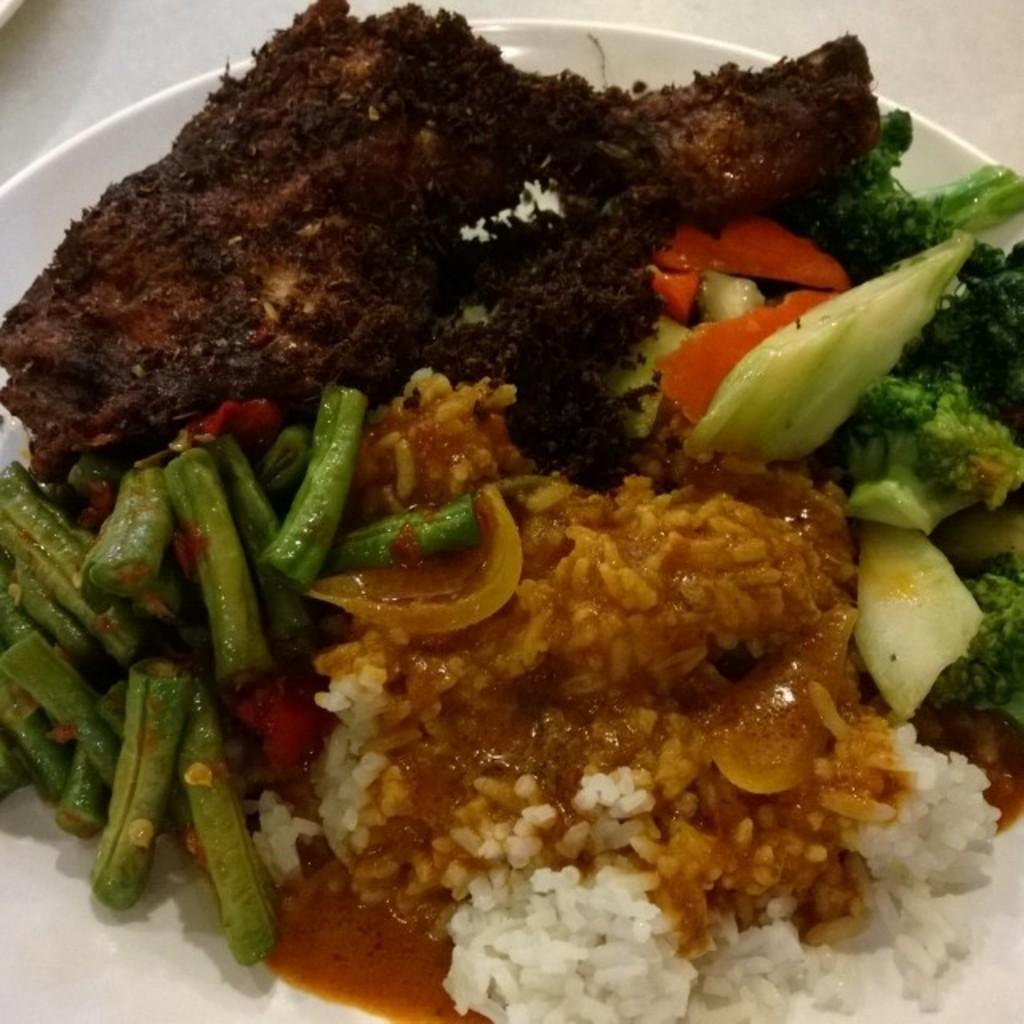What is present on the serving plate in the image? The serving plate contains different kinds of foods. Can you describe the types of foods on the serving plate? Unfortunately, the provided facts do not specify the types of foods on the serving plate. What type of creature can be seen drinking from a pail in the image? There is no creature present in the image, nor is there a pail. 